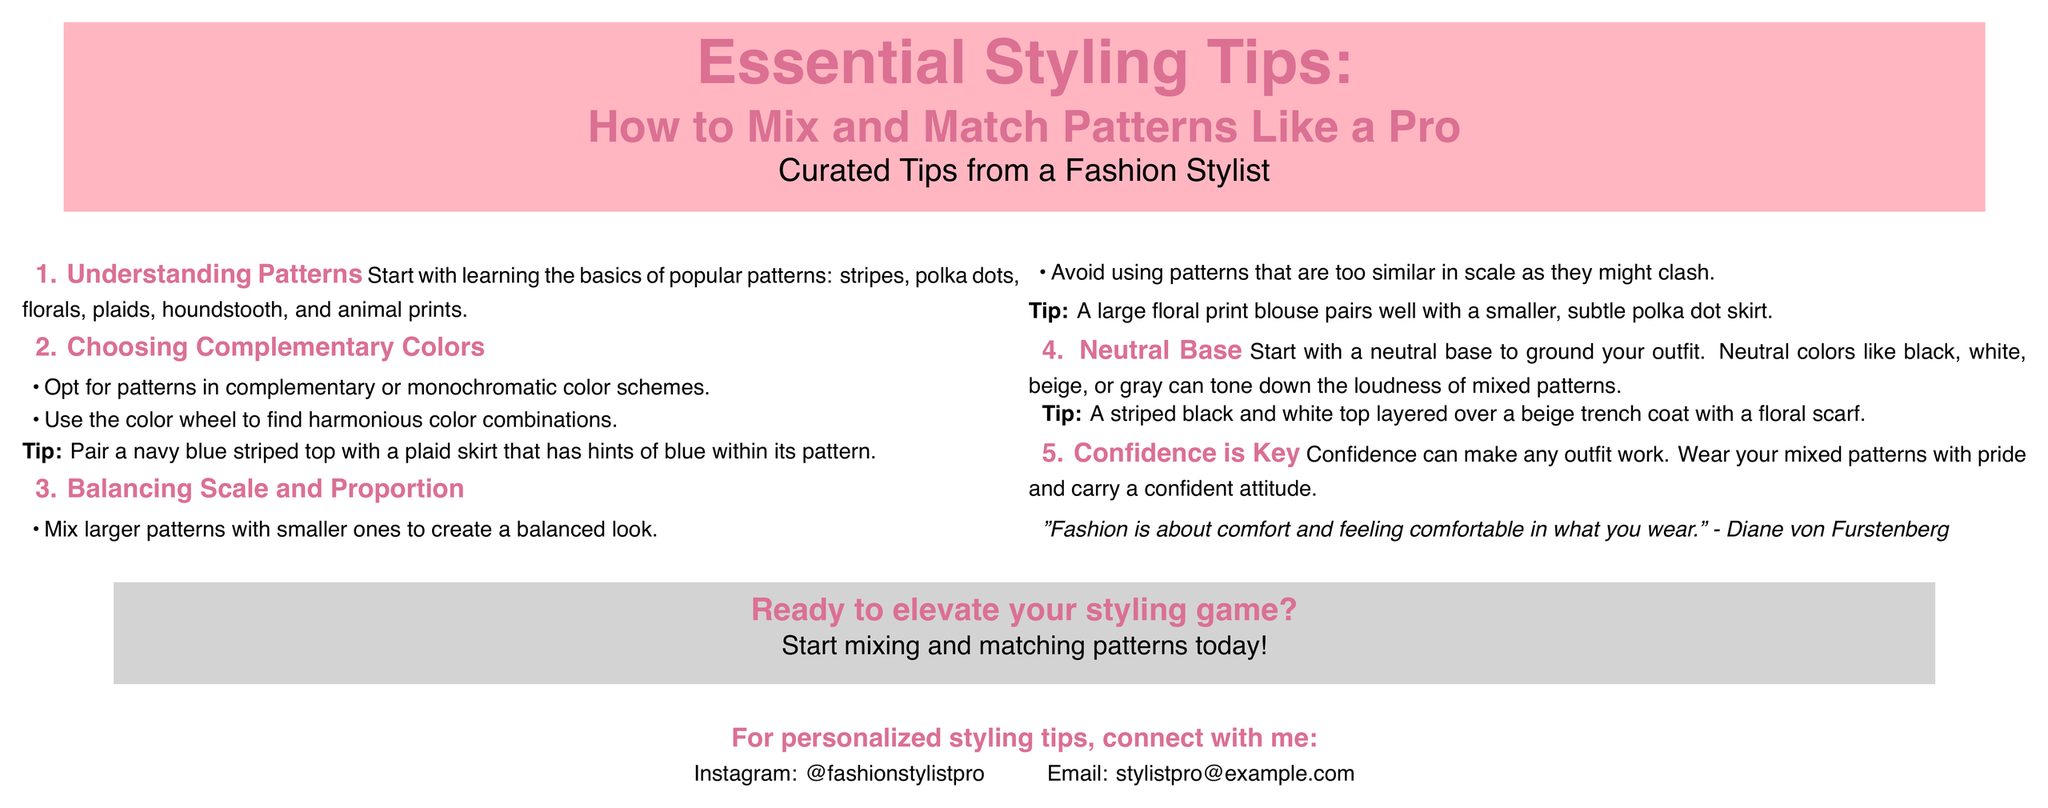What are the popular patterns mentioned? The document lists popular patterns as stripes, polka dots, florals, plaids, houndstooth, and animal prints.
Answer: stripes, polka dots, florals, plaids, houndstooth, animal prints What colors should you choose for complementary patterns? The document advises opting for patterns in complementary or monochromatic color schemes.
Answer: complementary or monochromatic What is recommended for a neutral base? The document suggests starting with a neutral base to ground your outfit, using colors like black, white, beige, or gray.
Answer: black, white, beige, gray What should you balance when mixing patterns? The document emphasizes balancing scale and proportion when mixing patterns.
Answer: scale and proportion Who is quoted in the document? The document features a quote by Diane von Furstenberg.
Answer: Diane von Furstenberg What is the goal of the poster? The document aims to provide essential styling tips on how to mix and match patterns.
Answer: essential styling tips How can confidence affect styling? The document states that confidence can make any outfit work.
Answer: confidence What is the Instagram handle for personalized tips? The document provides the Instagram handle as @fashionstylistpro.
Answer: @fashionstylistpro What type of document is this? The document is a poster focused on fashion styling tips.
Answer: poster 